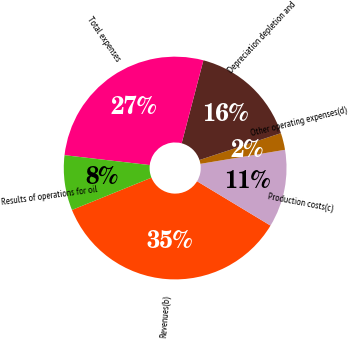Convert chart to OTSL. <chart><loc_0><loc_0><loc_500><loc_500><pie_chart><fcel>Revenues(b)<fcel>Production costs(c)<fcel>Other operating expenses(d)<fcel>Depreciation depletion and<fcel>Total expenses<fcel>Results of operations for oil<nl><fcel>35.22%<fcel>11.26%<fcel>2.45%<fcel>15.85%<fcel>27.24%<fcel>7.98%<nl></chart> 